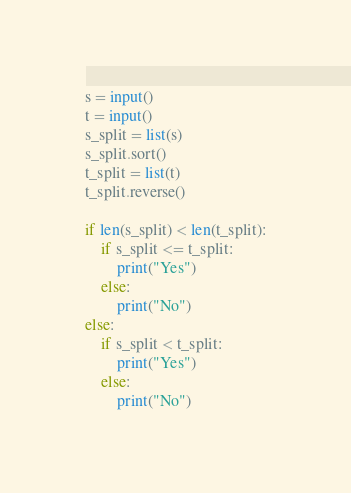<code> <loc_0><loc_0><loc_500><loc_500><_Python_>s = input()
t = input()
s_split = list(s)
s_split.sort()
t_split = list(t)
t_split.reverse()

if len(s_split) < len(t_split):
    if s_split <= t_split:
        print("Yes")
    else:
        print("No")
else:
    if s_split < t_split:
        print("Yes")
    else:
        print("No")</code> 